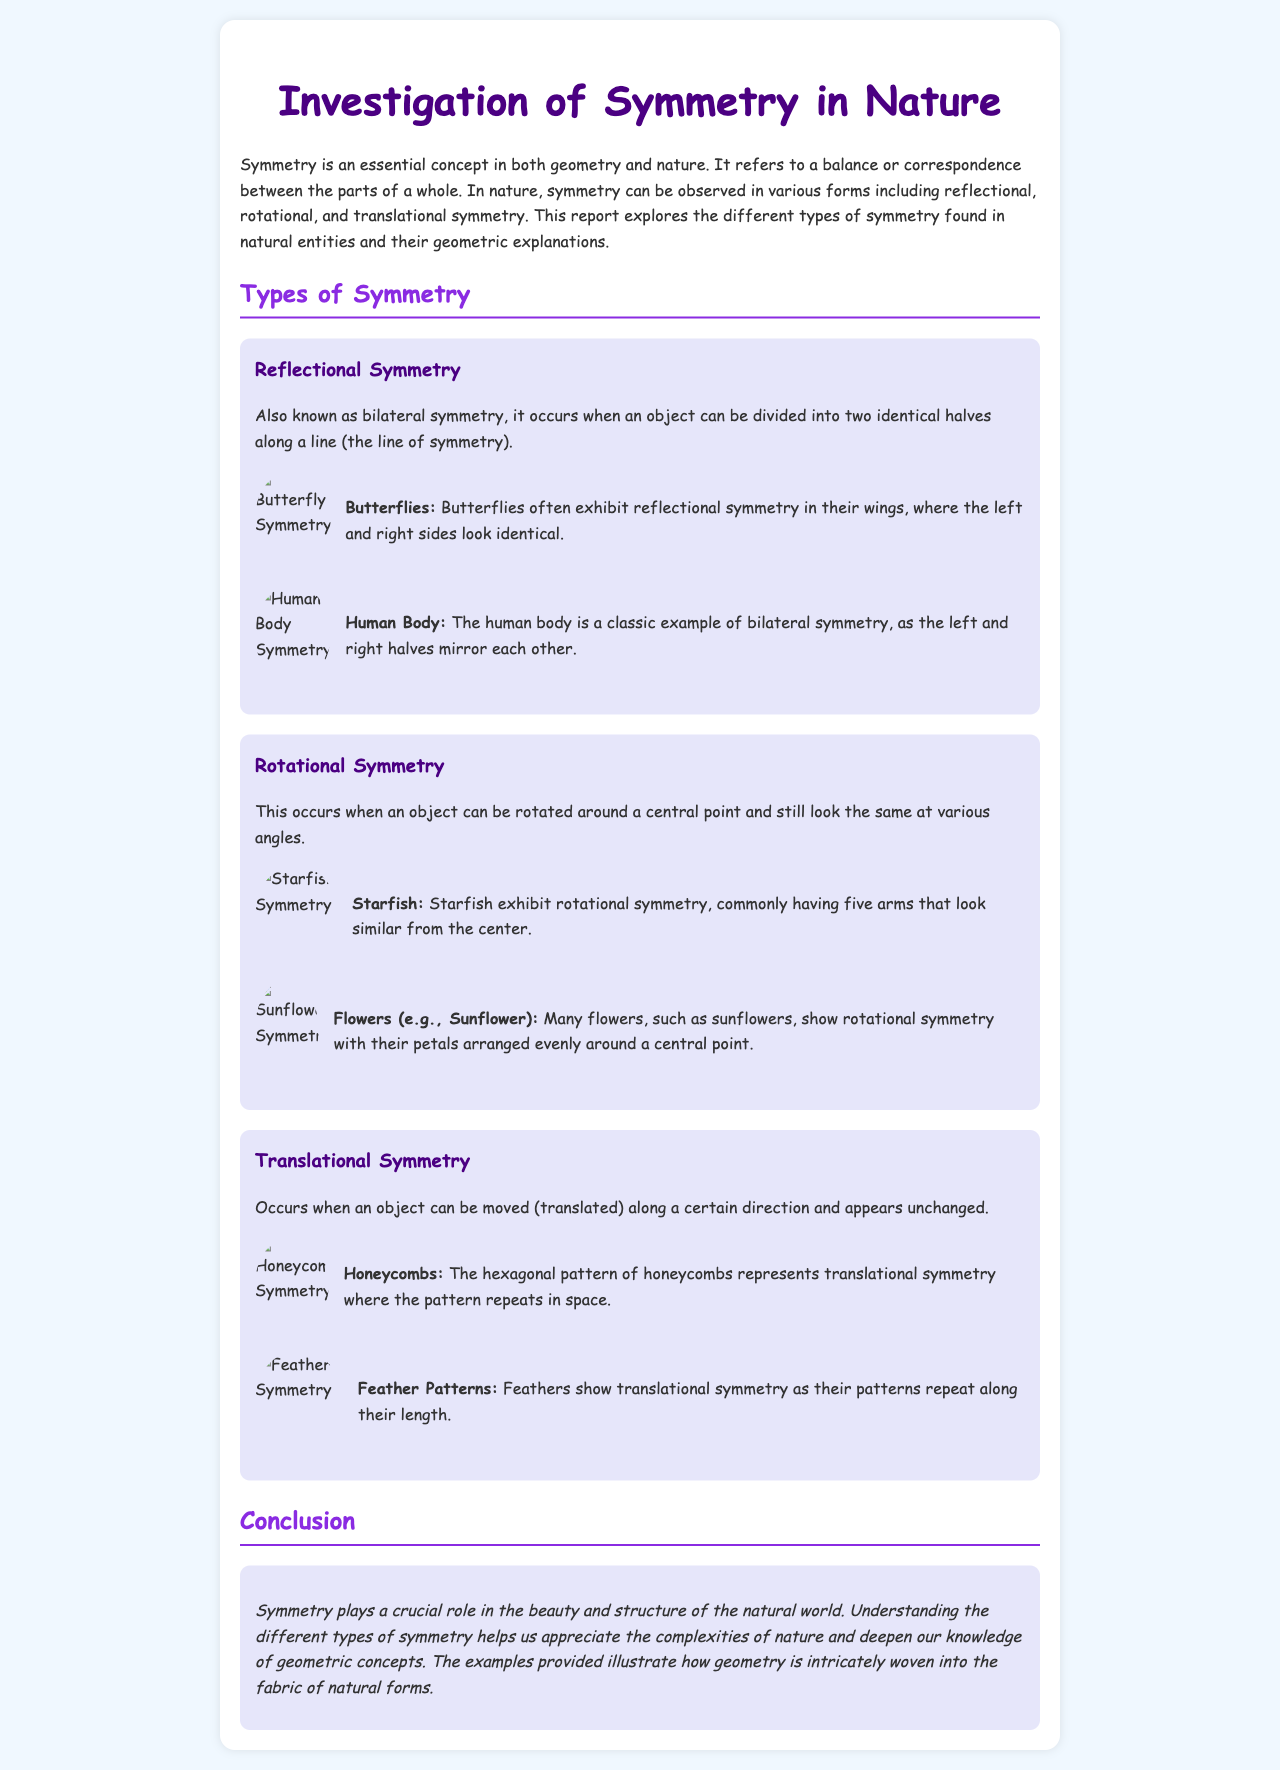What is the title of the report? The title of the report is written at the top of the document.
Answer: Investigation of Symmetry in Nature How many types of symmetry are discussed? The document lists three types of symmetry.
Answer: Three What is an example of reflectional symmetry mentioned in the report? The report cites specific examples to illustrate reflectional symmetry.
Answer: Butterflies What type of symmetry do starfish exhibit? The report describes the type of symmetry exhibited by starfish.
Answer: Rotational symmetry What geometric pattern do honeycombs represent? The document explains the type of symmetry shown in the structures of honeycombs.
Answer: Translational symmetry Which two natural entities show translational symmetry? The report lists specific examples of translational symmetry found in nature.
Answer: Honeycombs and Feather Patterns What color is used for the headings in the document? The color scheme for the headings is specified in the style definitions.
Answer: Purple What is the function of the line of symmetry in reflectional symmetry? The document defines the concept of reflectional symmetry and mentions the line involved.
Answer: Dividing into two identical halves What style is used for the text in the document? The document describes the chosen font style for the content.
Answer: Comic Sans MS 